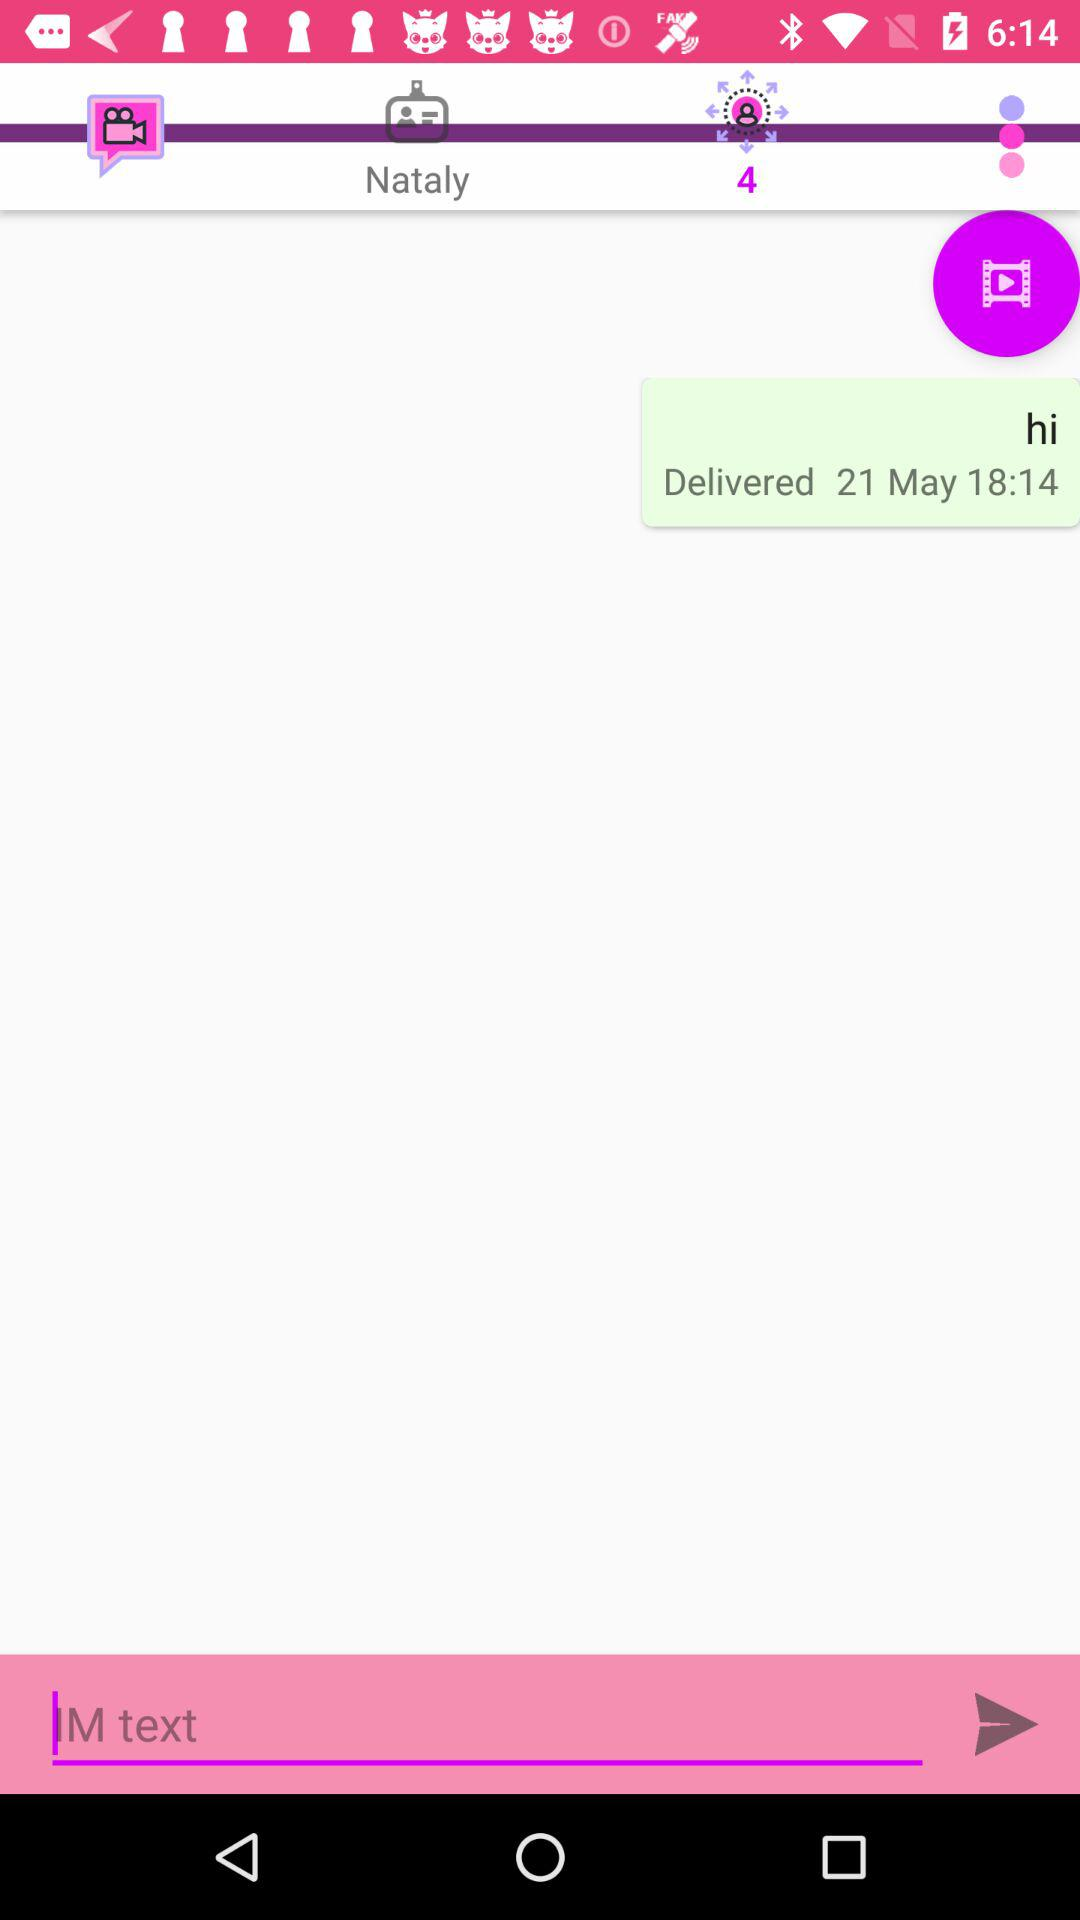What is the date of the message delivery? The message delivery date is May 21. 